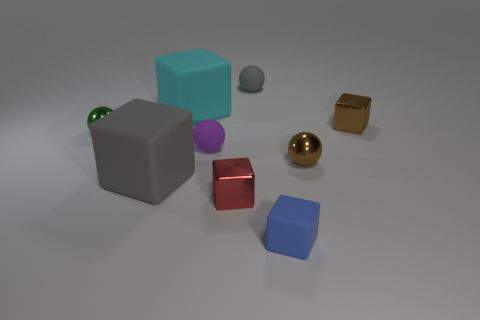Is there a big yellow cylinder?
Offer a terse response. No. How many large objects are either purple shiny cylinders or purple spheres?
Give a very brief answer. 0. Are there any other things of the same color as the tiny matte cube?
Your response must be concise. No. The blue thing that is made of the same material as the purple sphere is what shape?
Provide a short and direct response. Cube. What is the size of the matte cube that is to the right of the red object?
Offer a very short reply. Small. What is the shape of the blue thing?
Offer a very short reply. Cube. Do the cube behind the brown cube and the gray thing behind the brown block have the same size?
Give a very brief answer. No. There is a gray object on the left side of the large cube behind the gray matte object that is to the left of the small red metallic block; what is its size?
Make the answer very short. Large. What shape is the gray rubber object that is behind the metallic ball on the left side of the tiny rubber thing to the left of the small gray thing?
Provide a short and direct response. Sphere. What shape is the shiny thing in front of the tiny brown metal sphere?
Provide a short and direct response. Cube. 